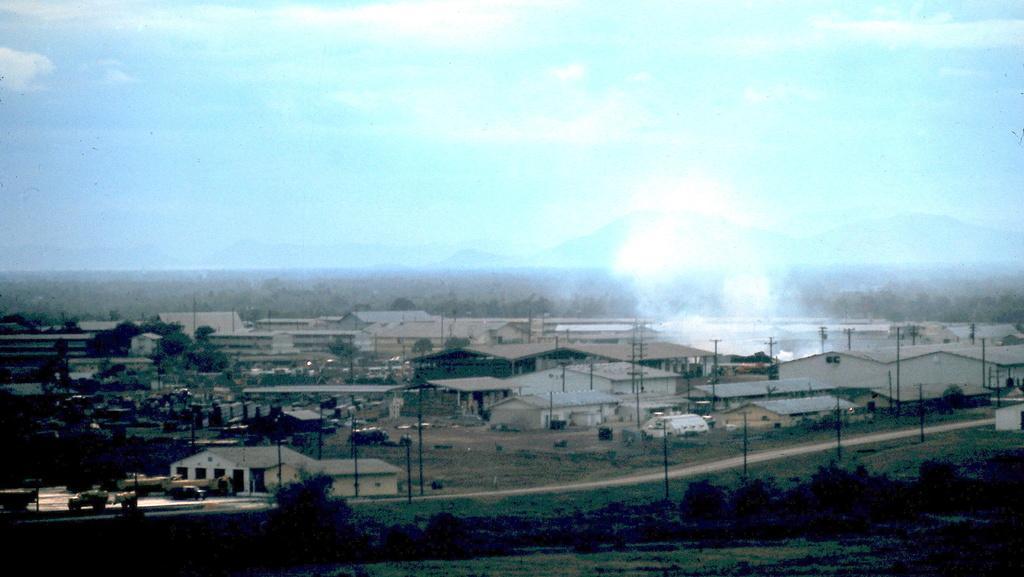How would you summarize this image in a sentence or two? In this picture I can see vehicles on the road. I can also see buildings, trees, poles and grass. In the background I can see the sky. 